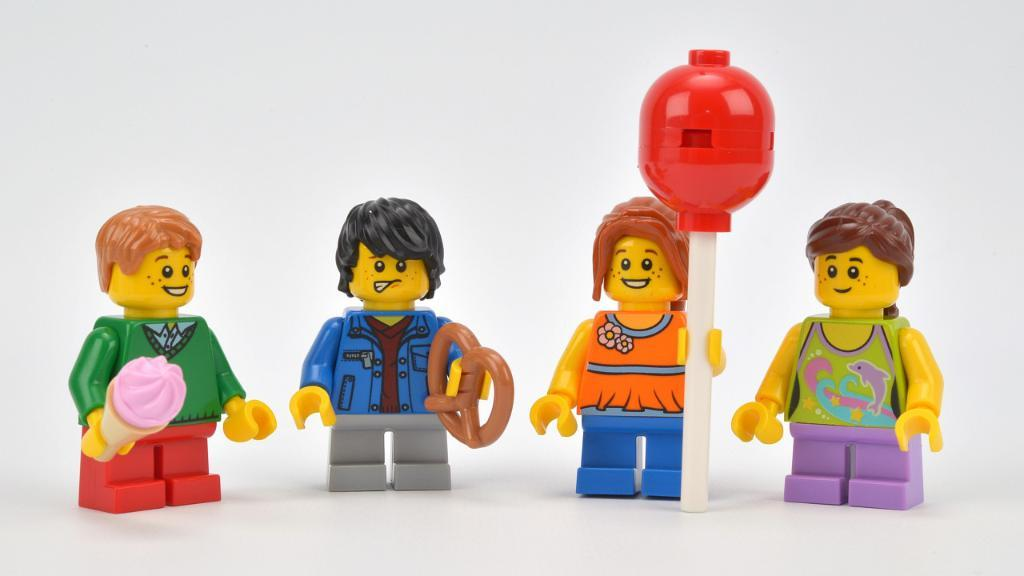What type of objects can be seen in the image? There are toys in the image. Can you describe the appearance of the toys? The toys are in different colors. What are the toys doing in the image? Some toys are holding objects. What type of chin can be seen on the toys in the image? There is no chin present on the toys in the image, as they are inanimate objects. 